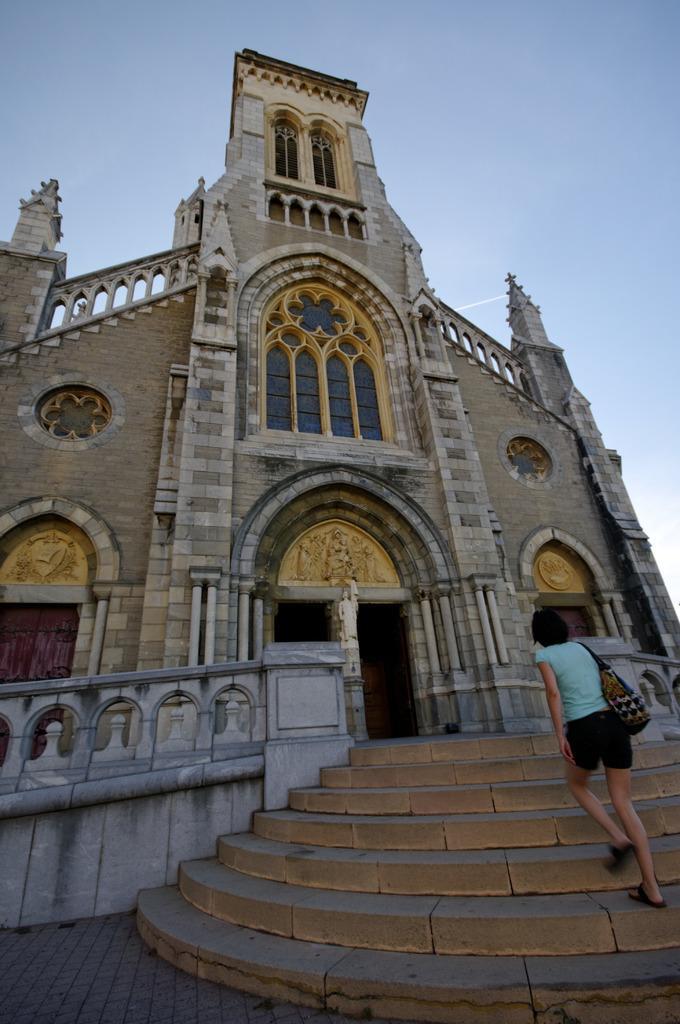Please provide a concise description of this image. In this image there is a girl wearing handbag is walking towards the entrance of the building. 